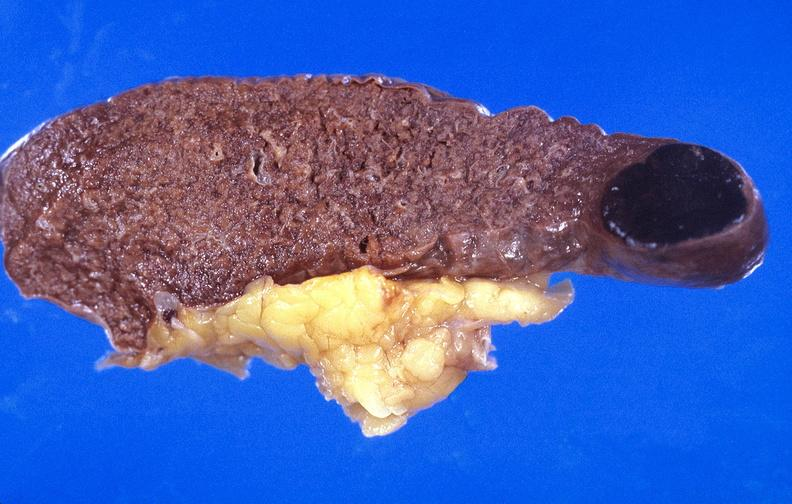what does this image show?
Answer the question using a single word or phrase. Spleen 